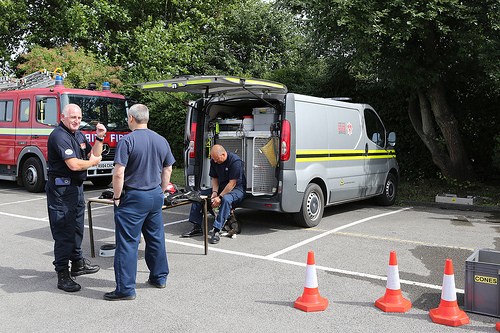<image>
Can you confirm if the shoe is on the man? No. The shoe is not positioned on the man. They may be near each other, but the shoe is not supported by or resting on top of the man. Is there a man behind the cone? No. The man is not behind the cone. From this viewpoint, the man appears to be positioned elsewhere in the scene. Is the cone to the left of the van? No. The cone is not to the left of the van. From this viewpoint, they have a different horizontal relationship. 